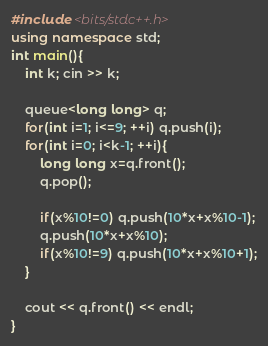Convert code to text. <code><loc_0><loc_0><loc_500><loc_500><_C++_>
#include <bits/stdc++.h>
using namespace std;
int main(){
	int k; cin >> k;

	queue<long long> q;
	for(int i=1; i<=9; ++i) q.push(i);
	for(int i=0; i<k-1; ++i){
		long long x=q.front();
		q.pop();

		if(x%10!=0) q.push(10*x+x%10-1);
		q.push(10*x+x%10);
		if(x%10!=9) q.push(10*x+x%10+1);
	}

	cout << q.front() << endl;
}</code> 